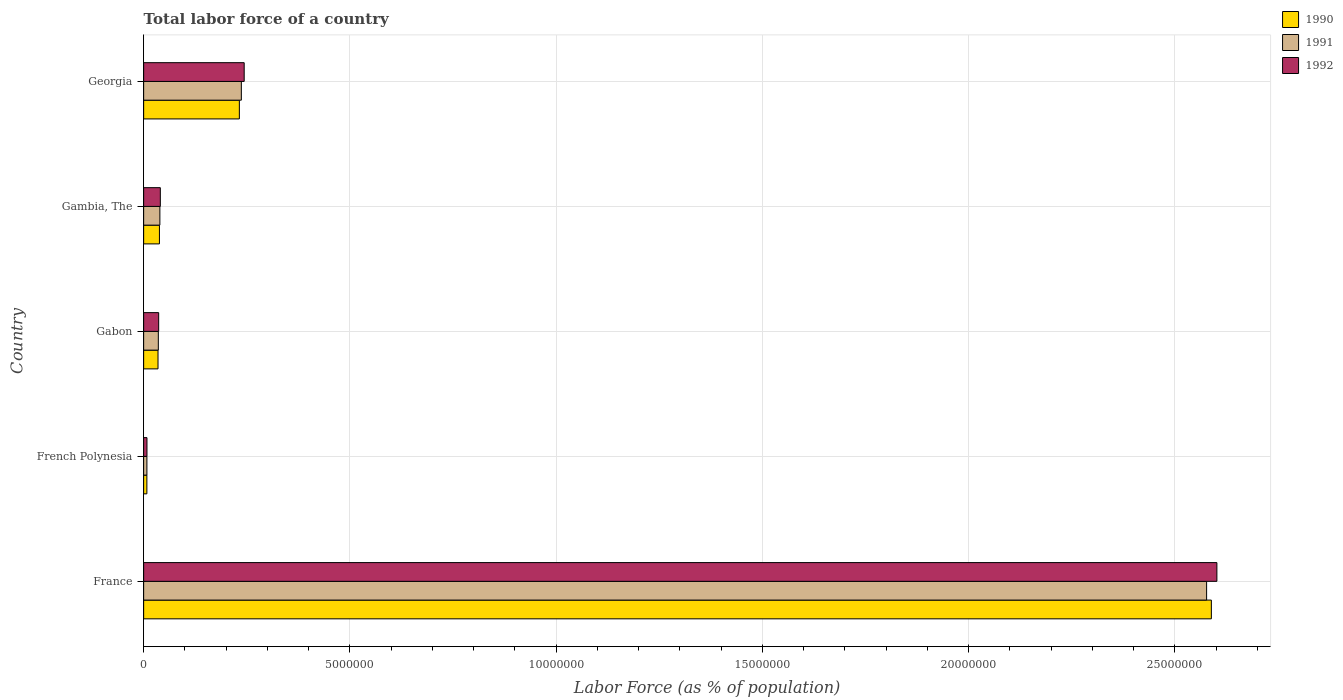How many groups of bars are there?
Ensure brevity in your answer.  5. Are the number of bars per tick equal to the number of legend labels?
Ensure brevity in your answer.  Yes. Are the number of bars on each tick of the Y-axis equal?
Offer a terse response. Yes. What is the label of the 1st group of bars from the top?
Your response must be concise. Georgia. In how many cases, is the number of bars for a given country not equal to the number of legend labels?
Your response must be concise. 0. What is the percentage of labor force in 1991 in Gambia, The?
Keep it short and to the point. 3.93e+05. Across all countries, what is the maximum percentage of labor force in 1991?
Offer a very short reply. 2.58e+07. Across all countries, what is the minimum percentage of labor force in 1991?
Keep it short and to the point. 7.91e+04. In which country was the percentage of labor force in 1992 minimum?
Make the answer very short. French Polynesia. What is the total percentage of labor force in 1992 in the graph?
Give a very brief answer. 2.93e+07. What is the difference between the percentage of labor force in 1990 in French Polynesia and that in Georgia?
Offer a terse response. -2.24e+06. What is the difference between the percentage of labor force in 1991 in Gabon and the percentage of labor force in 1990 in France?
Provide a short and direct response. -2.55e+07. What is the average percentage of labor force in 1990 per country?
Offer a very short reply. 5.80e+06. What is the difference between the percentage of labor force in 1992 and percentage of labor force in 1990 in Gabon?
Offer a very short reply. 1.61e+04. What is the ratio of the percentage of labor force in 1991 in France to that in Georgia?
Offer a terse response. 10.88. Is the difference between the percentage of labor force in 1992 in France and Gabon greater than the difference between the percentage of labor force in 1990 in France and Gabon?
Offer a very short reply. Yes. What is the difference between the highest and the second highest percentage of labor force in 1991?
Your answer should be compact. 2.34e+07. What is the difference between the highest and the lowest percentage of labor force in 1990?
Your response must be concise. 2.58e+07. Is the sum of the percentage of labor force in 1991 in French Polynesia and Georgia greater than the maximum percentage of labor force in 1992 across all countries?
Ensure brevity in your answer.  No. What does the 2nd bar from the bottom in Gambia, The represents?
Your answer should be compact. 1991. Are the values on the major ticks of X-axis written in scientific E-notation?
Give a very brief answer. No. Does the graph contain any zero values?
Make the answer very short. No. Does the graph contain grids?
Your response must be concise. Yes. Where does the legend appear in the graph?
Ensure brevity in your answer.  Top right. How are the legend labels stacked?
Your answer should be compact. Vertical. What is the title of the graph?
Offer a very short reply. Total labor force of a country. Does "1964" appear as one of the legend labels in the graph?
Offer a terse response. No. What is the label or title of the X-axis?
Provide a short and direct response. Labor Force (as % of population). What is the Labor Force (as % of population) in 1990 in France?
Provide a short and direct response. 2.59e+07. What is the Labor Force (as % of population) in 1991 in France?
Your answer should be compact. 2.58e+07. What is the Labor Force (as % of population) of 1992 in France?
Your answer should be compact. 2.60e+07. What is the Labor Force (as % of population) of 1990 in French Polynesia?
Give a very brief answer. 7.81e+04. What is the Labor Force (as % of population) of 1991 in French Polynesia?
Your answer should be very brief. 7.91e+04. What is the Labor Force (as % of population) of 1992 in French Polynesia?
Provide a short and direct response. 8.04e+04. What is the Labor Force (as % of population) in 1990 in Gabon?
Provide a short and direct response. 3.48e+05. What is the Labor Force (as % of population) in 1991 in Gabon?
Your response must be concise. 3.56e+05. What is the Labor Force (as % of population) in 1992 in Gabon?
Keep it short and to the point. 3.64e+05. What is the Labor Force (as % of population) of 1990 in Gambia, The?
Give a very brief answer. 3.83e+05. What is the Labor Force (as % of population) of 1991 in Gambia, The?
Ensure brevity in your answer.  3.93e+05. What is the Labor Force (as % of population) of 1992 in Gambia, The?
Make the answer very short. 4.04e+05. What is the Labor Force (as % of population) in 1990 in Georgia?
Give a very brief answer. 2.32e+06. What is the Labor Force (as % of population) in 1991 in Georgia?
Your response must be concise. 2.37e+06. What is the Labor Force (as % of population) in 1992 in Georgia?
Your answer should be very brief. 2.44e+06. Across all countries, what is the maximum Labor Force (as % of population) in 1990?
Your answer should be very brief. 2.59e+07. Across all countries, what is the maximum Labor Force (as % of population) of 1991?
Your answer should be very brief. 2.58e+07. Across all countries, what is the maximum Labor Force (as % of population) of 1992?
Offer a terse response. 2.60e+07. Across all countries, what is the minimum Labor Force (as % of population) of 1990?
Offer a very short reply. 7.81e+04. Across all countries, what is the minimum Labor Force (as % of population) of 1991?
Your response must be concise. 7.91e+04. Across all countries, what is the minimum Labor Force (as % of population) of 1992?
Offer a terse response. 8.04e+04. What is the total Labor Force (as % of population) of 1990 in the graph?
Give a very brief answer. 2.90e+07. What is the total Labor Force (as % of population) of 1991 in the graph?
Offer a terse response. 2.90e+07. What is the total Labor Force (as % of population) of 1992 in the graph?
Ensure brevity in your answer.  2.93e+07. What is the difference between the Labor Force (as % of population) in 1990 in France and that in French Polynesia?
Ensure brevity in your answer.  2.58e+07. What is the difference between the Labor Force (as % of population) of 1991 in France and that in French Polynesia?
Provide a succinct answer. 2.57e+07. What is the difference between the Labor Force (as % of population) of 1992 in France and that in French Polynesia?
Your response must be concise. 2.59e+07. What is the difference between the Labor Force (as % of population) of 1990 in France and that in Gabon?
Offer a terse response. 2.55e+07. What is the difference between the Labor Force (as % of population) in 1991 in France and that in Gabon?
Ensure brevity in your answer.  2.54e+07. What is the difference between the Labor Force (as % of population) in 1992 in France and that in Gabon?
Give a very brief answer. 2.57e+07. What is the difference between the Labor Force (as % of population) in 1990 in France and that in Gambia, The?
Your response must be concise. 2.55e+07. What is the difference between the Labor Force (as % of population) of 1991 in France and that in Gambia, The?
Offer a terse response. 2.54e+07. What is the difference between the Labor Force (as % of population) in 1992 in France and that in Gambia, The?
Your response must be concise. 2.56e+07. What is the difference between the Labor Force (as % of population) of 1990 in France and that in Georgia?
Your response must be concise. 2.36e+07. What is the difference between the Labor Force (as % of population) in 1991 in France and that in Georgia?
Keep it short and to the point. 2.34e+07. What is the difference between the Labor Force (as % of population) of 1992 in France and that in Georgia?
Give a very brief answer. 2.36e+07. What is the difference between the Labor Force (as % of population) in 1990 in French Polynesia and that in Gabon?
Your answer should be very brief. -2.70e+05. What is the difference between the Labor Force (as % of population) in 1991 in French Polynesia and that in Gabon?
Give a very brief answer. -2.77e+05. What is the difference between the Labor Force (as % of population) in 1992 in French Polynesia and that in Gabon?
Your response must be concise. -2.84e+05. What is the difference between the Labor Force (as % of population) of 1990 in French Polynesia and that in Gambia, The?
Make the answer very short. -3.05e+05. What is the difference between the Labor Force (as % of population) of 1991 in French Polynesia and that in Gambia, The?
Offer a very short reply. -3.14e+05. What is the difference between the Labor Force (as % of population) in 1992 in French Polynesia and that in Gambia, The?
Offer a terse response. -3.24e+05. What is the difference between the Labor Force (as % of population) of 1990 in French Polynesia and that in Georgia?
Make the answer very short. -2.24e+06. What is the difference between the Labor Force (as % of population) of 1991 in French Polynesia and that in Georgia?
Provide a short and direct response. -2.29e+06. What is the difference between the Labor Force (as % of population) in 1992 in French Polynesia and that in Georgia?
Offer a very short reply. -2.36e+06. What is the difference between the Labor Force (as % of population) of 1990 in Gabon and that in Gambia, The?
Your answer should be compact. -3.46e+04. What is the difference between the Labor Force (as % of population) of 1991 in Gabon and that in Gambia, The?
Give a very brief answer. -3.75e+04. What is the difference between the Labor Force (as % of population) in 1992 in Gabon and that in Gambia, The?
Keep it short and to the point. -3.99e+04. What is the difference between the Labor Force (as % of population) in 1990 in Gabon and that in Georgia?
Your response must be concise. -1.97e+06. What is the difference between the Labor Force (as % of population) in 1991 in Gabon and that in Georgia?
Ensure brevity in your answer.  -2.01e+06. What is the difference between the Labor Force (as % of population) of 1992 in Gabon and that in Georgia?
Offer a very short reply. -2.07e+06. What is the difference between the Labor Force (as % of population) in 1990 in Gambia, The and that in Georgia?
Your response must be concise. -1.94e+06. What is the difference between the Labor Force (as % of population) in 1991 in Gambia, The and that in Georgia?
Keep it short and to the point. -1.97e+06. What is the difference between the Labor Force (as % of population) in 1992 in Gambia, The and that in Georgia?
Make the answer very short. -2.03e+06. What is the difference between the Labor Force (as % of population) of 1990 in France and the Labor Force (as % of population) of 1991 in French Polynesia?
Your answer should be compact. 2.58e+07. What is the difference between the Labor Force (as % of population) in 1990 in France and the Labor Force (as % of population) in 1992 in French Polynesia?
Offer a very short reply. 2.58e+07. What is the difference between the Labor Force (as % of population) in 1991 in France and the Labor Force (as % of population) in 1992 in French Polynesia?
Give a very brief answer. 2.57e+07. What is the difference between the Labor Force (as % of population) in 1990 in France and the Labor Force (as % of population) in 1991 in Gabon?
Offer a very short reply. 2.55e+07. What is the difference between the Labor Force (as % of population) in 1990 in France and the Labor Force (as % of population) in 1992 in Gabon?
Provide a succinct answer. 2.55e+07. What is the difference between the Labor Force (as % of population) in 1991 in France and the Labor Force (as % of population) in 1992 in Gabon?
Your response must be concise. 2.54e+07. What is the difference between the Labor Force (as % of population) of 1990 in France and the Labor Force (as % of population) of 1991 in Gambia, The?
Offer a very short reply. 2.55e+07. What is the difference between the Labor Force (as % of population) of 1990 in France and the Labor Force (as % of population) of 1992 in Gambia, The?
Your answer should be very brief. 2.55e+07. What is the difference between the Labor Force (as % of population) of 1991 in France and the Labor Force (as % of population) of 1992 in Gambia, The?
Offer a terse response. 2.54e+07. What is the difference between the Labor Force (as % of population) of 1990 in France and the Labor Force (as % of population) of 1991 in Georgia?
Give a very brief answer. 2.35e+07. What is the difference between the Labor Force (as % of population) of 1990 in France and the Labor Force (as % of population) of 1992 in Georgia?
Your response must be concise. 2.34e+07. What is the difference between the Labor Force (as % of population) in 1991 in France and the Labor Force (as % of population) in 1992 in Georgia?
Your answer should be compact. 2.33e+07. What is the difference between the Labor Force (as % of population) of 1990 in French Polynesia and the Labor Force (as % of population) of 1991 in Gabon?
Offer a terse response. -2.78e+05. What is the difference between the Labor Force (as % of population) in 1990 in French Polynesia and the Labor Force (as % of population) in 1992 in Gabon?
Ensure brevity in your answer.  -2.86e+05. What is the difference between the Labor Force (as % of population) of 1991 in French Polynesia and the Labor Force (as % of population) of 1992 in Gabon?
Your answer should be compact. -2.85e+05. What is the difference between the Labor Force (as % of population) in 1990 in French Polynesia and the Labor Force (as % of population) in 1991 in Gambia, The?
Offer a terse response. -3.15e+05. What is the difference between the Labor Force (as % of population) of 1990 in French Polynesia and the Labor Force (as % of population) of 1992 in Gambia, The?
Offer a terse response. -3.26e+05. What is the difference between the Labor Force (as % of population) of 1991 in French Polynesia and the Labor Force (as % of population) of 1992 in Gambia, The?
Offer a terse response. -3.25e+05. What is the difference between the Labor Force (as % of population) in 1990 in French Polynesia and the Labor Force (as % of population) in 1991 in Georgia?
Provide a succinct answer. -2.29e+06. What is the difference between the Labor Force (as % of population) of 1990 in French Polynesia and the Labor Force (as % of population) of 1992 in Georgia?
Provide a short and direct response. -2.36e+06. What is the difference between the Labor Force (as % of population) of 1991 in French Polynesia and the Labor Force (as % of population) of 1992 in Georgia?
Offer a terse response. -2.36e+06. What is the difference between the Labor Force (as % of population) of 1990 in Gabon and the Labor Force (as % of population) of 1991 in Gambia, The?
Offer a terse response. -4.51e+04. What is the difference between the Labor Force (as % of population) of 1990 in Gabon and the Labor Force (as % of population) of 1992 in Gambia, The?
Make the answer very short. -5.60e+04. What is the difference between the Labor Force (as % of population) of 1991 in Gabon and the Labor Force (as % of population) of 1992 in Gambia, The?
Provide a short and direct response. -4.84e+04. What is the difference between the Labor Force (as % of population) of 1990 in Gabon and the Labor Force (as % of population) of 1991 in Georgia?
Offer a terse response. -2.02e+06. What is the difference between the Labor Force (as % of population) of 1990 in Gabon and the Labor Force (as % of population) of 1992 in Georgia?
Offer a very short reply. -2.09e+06. What is the difference between the Labor Force (as % of population) of 1991 in Gabon and the Labor Force (as % of population) of 1992 in Georgia?
Make the answer very short. -2.08e+06. What is the difference between the Labor Force (as % of population) of 1990 in Gambia, The and the Labor Force (as % of population) of 1991 in Georgia?
Provide a succinct answer. -1.99e+06. What is the difference between the Labor Force (as % of population) of 1990 in Gambia, The and the Labor Force (as % of population) of 1992 in Georgia?
Give a very brief answer. -2.05e+06. What is the difference between the Labor Force (as % of population) in 1991 in Gambia, The and the Labor Force (as % of population) in 1992 in Georgia?
Your response must be concise. -2.04e+06. What is the average Labor Force (as % of population) of 1990 per country?
Your answer should be very brief. 5.80e+06. What is the average Labor Force (as % of population) of 1991 per country?
Offer a very short reply. 5.79e+06. What is the average Labor Force (as % of population) of 1992 per country?
Keep it short and to the point. 5.86e+06. What is the difference between the Labor Force (as % of population) of 1990 and Labor Force (as % of population) of 1991 in France?
Your answer should be very brief. 1.15e+05. What is the difference between the Labor Force (as % of population) in 1990 and Labor Force (as % of population) in 1992 in France?
Provide a succinct answer. -1.34e+05. What is the difference between the Labor Force (as % of population) in 1991 and Labor Force (as % of population) in 1992 in France?
Offer a terse response. -2.49e+05. What is the difference between the Labor Force (as % of population) of 1990 and Labor Force (as % of population) of 1991 in French Polynesia?
Your answer should be very brief. -1056. What is the difference between the Labor Force (as % of population) of 1990 and Labor Force (as % of population) of 1992 in French Polynesia?
Your response must be concise. -2341. What is the difference between the Labor Force (as % of population) of 1991 and Labor Force (as % of population) of 1992 in French Polynesia?
Provide a short and direct response. -1285. What is the difference between the Labor Force (as % of population) in 1990 and Labor Force (as % of population) in 1991 in Gabon?
Your answer should be compact. -7576. What is the difference between the Labor Force (as % of population) in 1990 and Labor Force (as % of population) in 1992 in Gabon?
Your answer should be very brief. -1.61e+04. What is the difference between the Labor Force (as % of population) of 1991 and Labor Force (as % of population) of 1992 in Gabon?
Provide a short and direct response. -8544. What is the difference between the Labor Force (as % of population) in 1990 and Labor Force (as % of population) in 1991 in Gambia, The?
Ensure brevity in your answer.  -1.05e+04. What is the difference between the Labor Force (as % of population) in 1990 and Labor Force (as % of population) in 1992 in Gambia, The?
Offer a very short reply. -2.14e+04. What is the difference between the Labor Force (as % of population) of 1991 and Labor Force (as % of population) of 1992 in Gambia, The?
Your response must be concise. -1.09e+04. What is the difference between the Labor Force (as % of population) in 1990 and Labor Force (as % of population) in 1991 in Georgia?
Your answer should be compact. -4.79e+04. What is the difference between the Labor Force (as % of population) of 1990 and Labor Force (as % of population) of 1992 in Georgia?
Keep it short and to the point. -1.17e+05. What is the difference between the Labor Force (as % of population) of 1991 and Labor Force (as % of population) of 1992 in Georgia?
Your answer should be very brief. -6.92e+04. What is the ratio of the Labor Force (as % of population) of 1990 in France to that in French Polynesia?
Your answer should be compact. 331.55. What is the ratio of the Labor Force (as % of population) of 1991 in France to that in French Polynesia?
Ensure brevity in your answer.  325.67. What is the ratio of the Labor Force (as % of population) of 1992 in France to that in French Polynesia?
Offer a terse response. 323.57. What is the ratio of the Labor Force (as % of population) of 1990 in France to that in Gabon?
Offer a terse response. 74.32. What is the ratio of the Labor Force (as % of population) in 1991 in France to that in Gabon?
Make the answer very short. 72.41. What is the ratio of the Labor Force (as % of population) in 1992 in France to that in Gabon?
Your response must be concise. 71.4. What is the ratio of the Labor Force (as % of population) of 1990 in France to that in Gambia, The?
Offer a terse response. 67.61. What is the ratio of the Labor Force (as % of population) of 1991 in France to that in Gambia, The?
Offer a very short reply. 65.51. What is the ratio of the Labor Force (as % of population) in 1992 in France to that in Gambia, The?
Your answer should be compact. 64.36. What is the ratio of the Labor Force (as % of population) of 1990 in France to that in Georgia?
Provide a succinct answer. 11.16. What is the ratio of the Labor Force (as % of population) in 1991 in France to that in Georgia?
Your response must be concise. 10.88. What is the ratio of the Labor Force (as % of population) of 1992 in France to that in Georgia?
Your answer should be compact. 10.67. What is the ratio of the Labor Force (as % of population) in 1990 in French Polynesia to that in Gabon?
Provide a succinct answer. 0.22. What is the ratio of the Labor Force (as % of population) of 1991 in French Polynesia to that in Gabon?
Provide a short and direct response. 0.22. What is the ratio of the Labor Force (as % of population) in 1992 in French Polynesia to that in Gabon?
Provide a short and direct response. 0.22. What is the ratio of the Labor Force (as % of population) in 1990 in French Polynesia to that in Gambia, The?
Ensure brevity in your answer.  0.2. What is the ratio of the Labor Force (as % of population) of 1991 in French Polynesia to that in Gambia, The?
Provide a succinct answer. 0.2. What is the ratio of the Labor Force (as % of population) of 1992 in French Polynesia to that in Gambia, The?
Give a very brief answer. 0.2. What is the ratio of the Labor Force (as % of population) in 1990 in French Polynesia to that in Georgia?
Keep it short and to the point. 0.03. What is the ratio of the Labor Force (as % of population) in 1991 in French Polynesia to that in Georgia?
Your answer should be compact. 0.03. What is the ratio of the Labor Force (as % of population) of 1992 in French Polynesia to that in Georgia?
Your answer should be very brief. 0.03. What is the ratio of the Labor Force (as % of population) in 1990 in Gabon to that in Gambia, The?
Provide a succinct answer. 0.91. What is the ratio of the Labor Force (as % of population) in 1991 in Gabon to that in Gambia, The?
Your answer should be very brief. 0.9. What is the ratio of the Labor Force (as % of population) in 1992 in Gabon to that in Gambia, The?
Ensure brevity in your answer.  0.9. What is the ratio of the Labor Force (as % of population) in 1990 in Gabon to that in Georgia?
Your answer should be compact. 0.15. What is the ratio of the Labor Force (as % of population) in 1991 in Gabon to that in Georgia?
Ensure brevity in your answer.  0.15. What is the ratio of the Labor Force (as % of population) of 1992 in Gabon to that in Georgia?
Keep it short and to the point. 0.15. What is the ratio of the Labor Force (as % of population) of 1990 in Gambia, The to that in Georgia?
Your answer should be very brief. 0.17. What is the ratio of the Labor Force (as % of population) of 1991 in Gambia, The to that in Georgia?
Your response must be concise. 0.17. What is the ratio of the Labor Force (as % of population) in 1992 in Gambia, The to that in Georgia?
Make the answer very short. 0.17. What is the difference between the highest and the second highest Labor Force (as % of population) of 1990?
Make the answer very short. 2.36e+07. What is the difference between the highest and the second highest Labor Force (as % of population) of 1991?
Your answer should be very brief. 2.34e+07. What is the difference between the highest and the second highest Labor Force (as % of population) in 1992?
Make the answer very short. 2.36e+07. What is the difference between the highest and the lowest Labor Force (as % of population) in 1990?
Your response must be concise. 2.58e+07. What is the difference between the highest and the lowest Labor Force (as % of population) in 1991?
Offer a very short reply. 2.57e+07. What is the difference between the highest and the lowest Labor Force (as % of population) in 1992?
Give a very brief answer. 2.59e+07. 